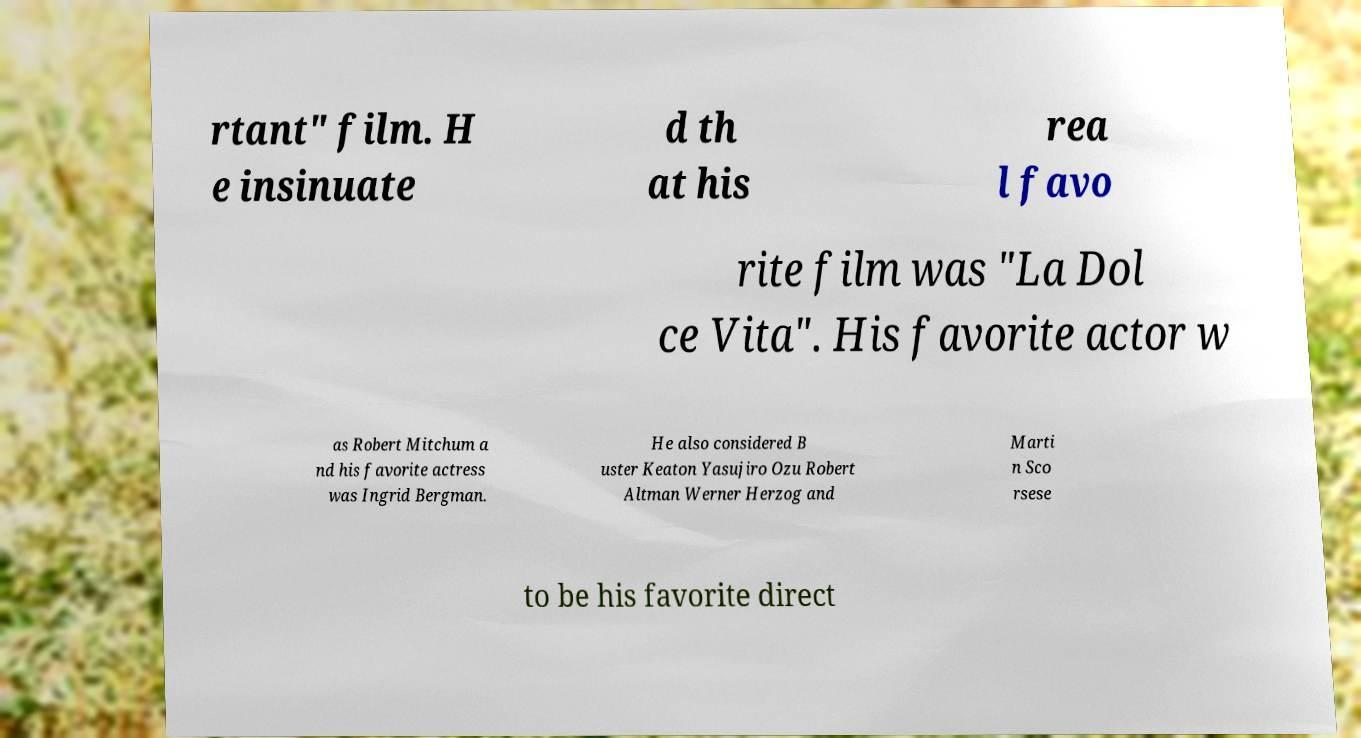For documentation purposes, I need the text within this image transcribed. Could you provide that? rtant" film. H e insinuate d th at his rea l favo rite film was "La Dol ce Vita". His favorite actor w as Robert Mitchum a nd his favorite actress was Ingrid Bergman. He also considered B uster Keaton Yasujiro Ozu Robert Altman Werner Herzog and Marti n Sco rsese to be his favorite direct 